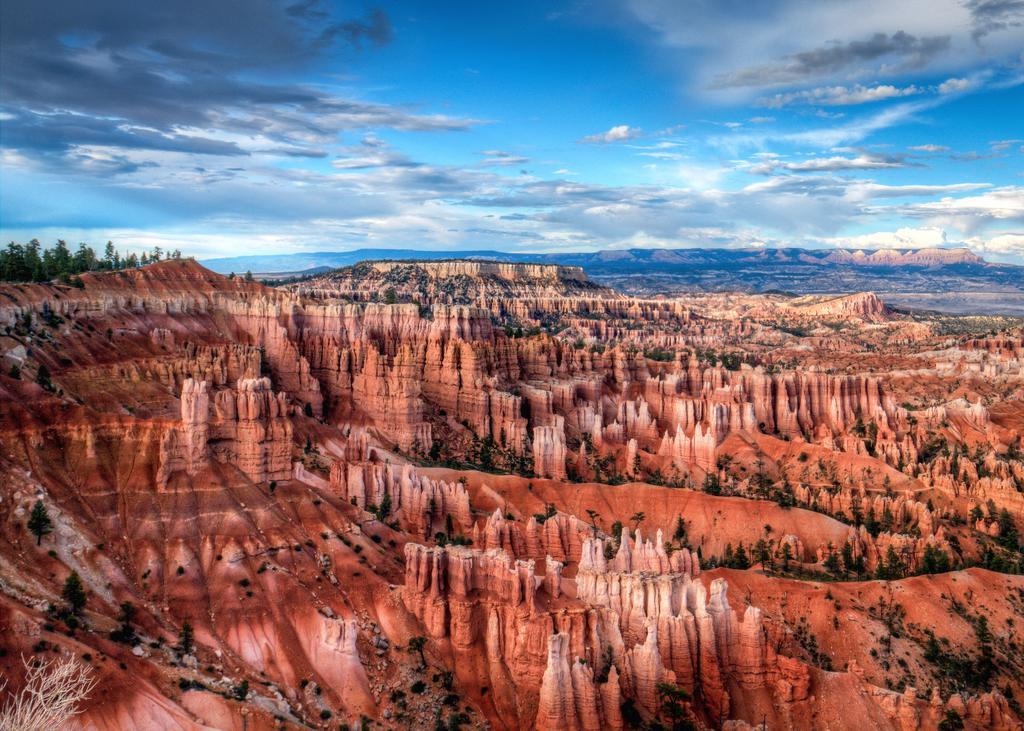Describe this image in one or two sentences. In this image in the center there are rocks and on the left side there are trees and the sky is cloudy. 